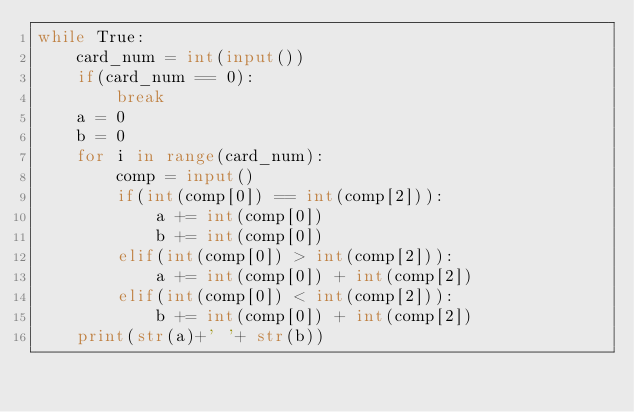<code> <loc_0><loc_0><loc_500><loc_500><_Python_>while True:
    card_num = int(input())
    if(card_num == 0):
        break
    a = 0
    b = 0
    for i in range(card_num):
        comp = input()
        if(int(comp[0]) == int(comp[2])):
            a += int(comp[0])
            b += int(comp[0])
        elif(int(comp[0]) > int(comp[2])):
            a += int(comp[0]) + int(comp[2])
        elif(int(comp[0]) < int(comp[2])):
            b += int(comp[0]) + int(comp[2])
    print(str(a)+' '+ str(b))</code> 